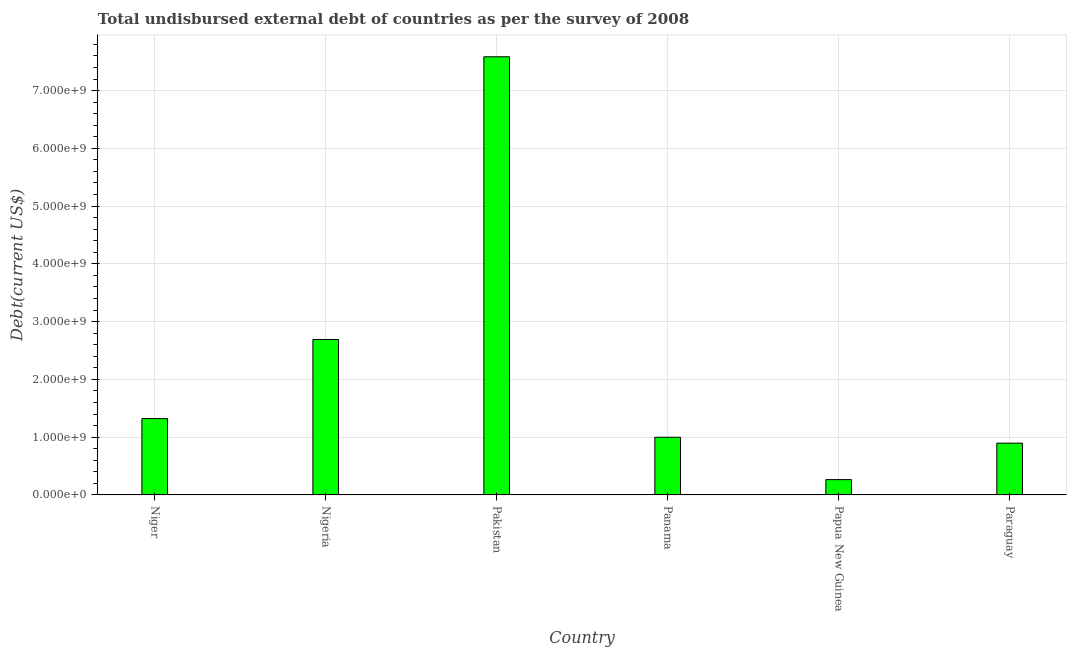Does the graph contain grids?
Offer a very short reply. Yes. What is the title of the graph?
Your answer should be compact. Total undisbursed external debt of countries as per the survey of 2008. What is the label or title of the Y-axis?
Your answer should be very brief. Debt(current US$). What is the total debt in Papua New Guinea?
Give a very brief answer. 2.65e+08. Across all countries, what is the maximum total debt?
Ensure brevity in your answer.  7.58e+09. Across all countries, what is the minimum total debt?
Keep it short and to the point. 2.65e+08. In which country was the total debt minimum?
Offer a very short reply. Papua New Guinea. What is the sum of the total debt?
Offer a terse response. 1.38e+1. What is the difference between the total debt in Niger and Nigeria?
Give a very brief answer. -1.37e+09. What is the average total debt per country?
Give a very brief answer. 2.29e+09. What is the median total debt?
Provide a succinct answer. 1.16e+09. What is the ratio of the total debt in Nigeria to that in Panama?
Make the answer very short. 2.69. What is the difference between the highest and the second highest total debt?
Make the answer very short. 4.89e+09. What is the difference between the highest and the lowest total debt?
Your response must be concise. 7.32e+09. In how many countries, is the total debt greater than the average total debt taken over all countries?
Keep it short and to the point. 2. Are all the bars in the graph horizontal?
Ensure brevity in your answer.  No. How many countries are there in the graph?
Your answer should be compact. 6. What is the difference between two consecutive major ticks on the Y-axis?
Offer a terse response. 1.00e+09. What is the Debt(current US$) of Niger?
Offer a terse response. 1.32e+09. What is the Debt(current US$) of Nigeria?
Keep it short and to the point. 2.69e+09. What is the Debt(current US$) of Pakistan?
Ensure brevity in your answer.  7.58e+09. What is the Debt(current US$) of Panama?
Provide a succinct answer. 9.98e+08. What is the Debt(current US$) in Papua New Guinea?
Offer a very short reply. 2.65e+08. What is the Debt(current US$) of Paraguay?
Your answer should be very brief. 8.96e+08. What is the difference between the Debt(current US$) in Niger and Nigeria?
Your answer should be compact. -1.37e+09. What is the difference between the Debt(current US$) in Niger and Pakistan?
Provide a succinct answer. -6.26e+09. What is the difference between the Debt(current US$) in Niger and Panama?
Keep it short and to the point. 3.24e+08. What is the difference between the Debt(current US$) in Niger and Papua New Guinea?
Offer a very short reply. 1.06e+09. What is the difference between the Debt(current US$) in Niger and Paraguay?
Offer a very short reply. 4.26e+08. What is the difference between the Debt(current US$) in Nigeria and Pakistan?
Your answer should be compact. -4.89e+09. What is the difference between the Debt(current US$) in Nigeria and Panama?
Keep it short and to the point. 1.69e+09. What is the difference between the Debt(current US$) in Nigeria and Papua New Guinea?
Give a very brief answer. 2.43e+09. What is the difference between the Debt(current US$) in Nigeria and Paraguay?
Keep it short and to the point. 1.79e+09. What is the difference between the Debt(current US$) in Pakistan and Panama?
Offer a terse response. 6.59e+09. What is the difference between the Debt(current US$) in Pakistan and Papua New Guinea?
Keep it short and to the point. 7.32e+09. What is the difference between the Debt(current US$) in Pakistan and Paraguay?
Offer a very short reply. 6.69e+09. What is the difference between the Debt(current US$) in Panama and Papua New Guinea?
Provide a short and direct response. 7.33e+08. What is the difference between the Debt(current US$) in Panama and Paraguay?
Provide a succinct answer. 1.02e+08. What is the difference between the Debt(current US$) in Papua New Guinea and Paraguay?
Your answer should be very brief. -6.31e+08. What is the ratio of the Debt(current US$) in Niger to that in Nigeria?
Your answer should be compact. 0.49. What is the ratio of the Debt(current US$) in Niger to that in Pakistan?
Provide a succinct answer. 0.17. What is the ratio of the Debt(current US$) in Niger to that in Panama?
Give a very brief answer. 1.32. What is the ratio of the Debt(current US$) in Niger to that in Papua New Guinea?
Make the answer very short. 4.99. What is the ratio of the Debt(current US$) in Niger to that in Paraguay?
Provide a succinct answer. 1.48. What is the ratio of the Debt(current US$) in Nigeria to that in Pakistan?
Provide a short and direct response. 0.35. What is the ratio of the Debt(current US$) in Nigeria to that in Panama?
Offer a terse response. 2.69. What is the ratio of the Debt(current US$) in Nigeria to that in Papua New Guinea?
Your response must be concise. 10.15. What is the ratio of the Debt(current US$) in Nigeria to that in Paraguay?
Give a very brief answer. 3. What is the ratio of the Debt(current US$) in Pakistan to that in Panama?
Offer a terse response. 7.6. What is the ratio of the Debt(current US$) in Pakistan to that in Papua New Guinea?
Your answer should be compact. 28.6. What is the ratio of the Debt(current US$) in Pakistan to that in Paraguay?
Your response must be concise. 8.46. What is the ratio of the Debt(current US$) in Panama to that in Papua New Guinea?
Offer a very short reply. 3.77. What is the ratio of the Debt(current US$) in Panama to that in Paraguay?
Offer a very short reply. 1.11. What is the ratio of the Debt(current US$) in Papua New Guinea to that in Paraguay?
Provide a short and direct response. 0.3. 